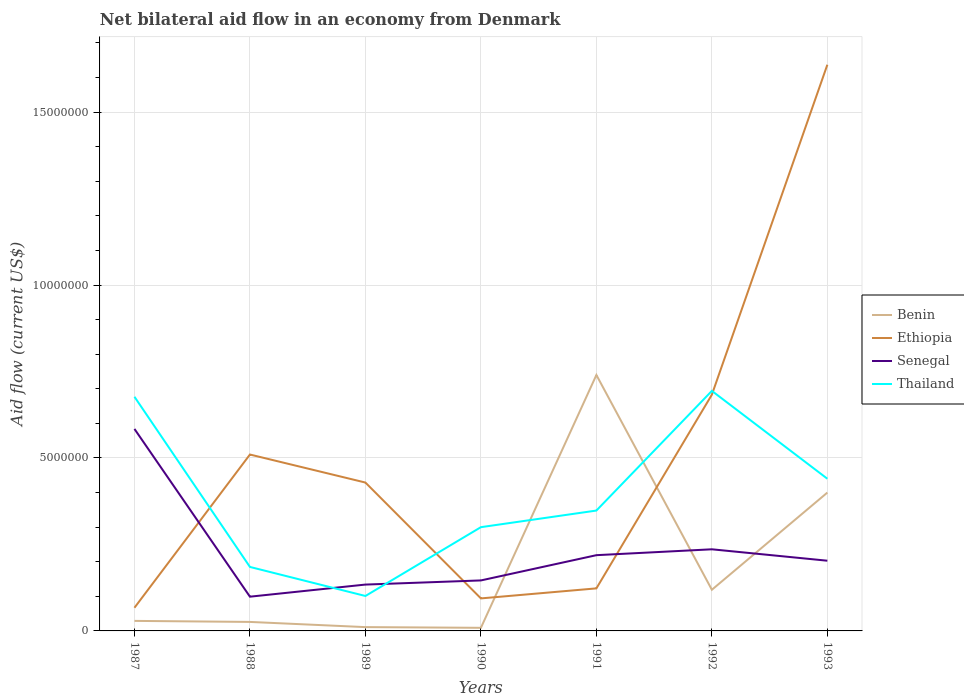Does the line corresponding to Benin intersect with the line corresponding to Ethiopia?
Offer a terse response. Yes. What is the total net bilateral aid flow in Thailand in the graph?
Your response must be concise. -4.80e+05. What is the difference between the highest and the second highest net bilateral aid flow in Ethiopia?
Provide a short and direct response. 1.57e+07. How many lines are there?
Your answer should be very brief. 4. Are the values on the major ticks of Y-axis written in scientific E-notation?
Your answer should be compact. No. Where does the legend appear in the graph?
Your response must be concise. Center right. How are the legend labels stacked?
Make the answer very short. Vertical. What is the title of the graph?
Offer a very short reply. Net bilateral aid flow in an economy from Denmark. What is the label or title of the X-axis?
Offer a very short reply. Years. What is the Aid flow (current US$) of Ethiopia in 1987?
Give a very brief answer. 6.70e+05. What is the Aid flow (current US$) in Senegal in 1987?
Ensure brevity in your answer.  5.84e+06. What is the Aid flow (current US$) in Thailand in 1987?
Your response must be concise. 6.77e+06. What is the Aid flow (current US$) in Ethiopia in 1988?
Offer a very short reply. 5.10e+06. What is the Aid flow (current US$) in Senegal in 1988?
Provide a short and direct response. 9.90e+05. What is the Aid flow (current US$) of Thailand in 1988?
Give a very brief answer. 1.85e+06. What is the Aid flow (current US$) in Ethiopia in 1989?
Your answer should be compact. 4.29e+06. What is the Aid flow (current US$) of Senegal in 1989?
Provide a succinct answer. 1.34e+06. What is the Aid flow (current US$) of Thailand in 1989?
Your answer should be compact. 1.01e+06. What is the Aid flow (current US$) in Ethiopia in 1990?
Your response must be concise. 9.40e+05. What is the Aid flow (current US$) in Senegal in 1990?
Give a very brief answer. 1.46e+06. What is the Aid flow (current US$) in Thailand in 1990?
Your answer should be compact. 3.00e+06. What is the Aid flow (current US$) in Benin in 1991?
Your answer should be compact. 7.40e+06. What is the Aid flow (current US$) in Ethiopia in 1991?
Ensure brevity in your answer.  1.23e+06. What is the Aid flow (current US$) in Senegal in 1991?
Your answer should be compact. 2.19e+06. What is the Aid flow (current US$) of Thailand in 1991?
Provide a short and direct response. 3.48e+06. What is the Aid flow (current US$) of Benin in 1992?
Make the answer very short. 1.19e+06. What is the Aid flow (current US$) in Ethiopia in 1992?
Your response must be concise. 6.83e+06. What is the Aid flow (current US$) of Senegal in 1992?
Provide a short and direct response. 2.36e+06. What is the Aid flow (current US$) of Thailand in 1992?
Your answer should be very brief. 6.94e+06. What is the Aid flow (current US$) in Benin in 1993?
Offer a terse response. 4.00e+06. What is the Aid flow (current US$) of Ethiopia in 1993?
Provide a succinct answer. 1.64e+07. What is the Aid flow (current US$) of Senegal in 1993?
Keep it short and to the point. 2.03e+06. What is the Aid flow (current US$) in Thailand in 1993?
Your answer should be compact. 4.40e+06. Across all years, what is the maximum Aid flow (current US$) of Benin?
Provide a succinct answer. 7.40e+06. Across all years, what is the maximum Aid flow (current US$) of Ethiopia?
Provide a short and direct response. 1.64e+07. Across all years, what is the maximum Aid flow (current US$) in Senegal?
Ensure brevity in your answer.  5.84e+06. Across all years, what is the maximum Aid flow (current US$) in Thailand?
Provide a succinct answer. 6.94e+06. Across all years, what is the minimum Aid flow (current US$) of Ethiopia?
Your answer should be compact. 6.70e+05. Across all years, what is the minimum Aid flow (current US$) in Senegal?
Provide a succinct answer. 9.90e+05. Across all years, what is the minimum Aid flow (current US$) in Thailand?
Offer a very short reply. 1.01e+06. What is the total Aid flow (current US$) of Benin in the graph?
Give a very brief answer. 1.33e+07. What is the total Aid flow (current US$) of Ethiopia in the graph?
Offer a terse response. 3.54e+07. What is the total Aid flow (current US$) of Senegal in the graph?
Offer a very short reply. 1.62e+07. What is the total Aid flow (current US$) of Thailand in the graph?
Give a very brief answer. 2.74e+07. What is the difference between the Aid flow (current US$) of Ethiopia in 1987 and that in 1988?
Give a very brief answer. -4.43e+06. What is the difference between the Aid flow (current US$) of Senegal in 1987 and that in 1988?
Your answer should be compact. 4.85e+06. What is the difference between the Aid flow (current US$) of Thailand in 1987 and that in 1988?
Provide a short and direct response. 4.92e+06. What is the difference between the Aid flow (current US$) of Benin in 1987 and that in 1989?
Your answer should be very brief. 1.80e+05. What is the difference between the Aid flow (current US$) in Ethiopia in 1987 and that in 1989?
Your response must be concise. -3.62e+06. What is the difference between the Aid flow (current US$) of Senegal in 1987 and that in 1989?
Give a very brief answer. 4.50e+06. What is the difference between the Aid flow (current US$) of Thailand in 1987 and that in 1989?
Ensure brevity in your answer.  5.76e+06. What is the difference between the Aid flow (current US$) in Benin in 1987 and that in 1990?
Provide a succinct answer. 2.00e+05. What is the difference between the Aid flow (current US$) in Senegal in 1987 and that in 1990?
Your response must be concise. 4.38e+06. What is the difference between the Aid flow (current US$) of Thailand in 1987 and that in 1990?
Provide a short and direct response. 3.77e+06. What is the difference between the Aid flow (current US$) of Benin in 1987 and that in 1991?
Keep it short and to the point. -7.11e+06. What is the difference between the Aid flow (current US$) of Ethiopia in 1987 and that in 1991?
Provide a succinct answer. -5.60e+05. What is the difference between the Aid flow (current US$) in Senegal in 1987 and that in 1991?
Provide a short and direct response. 3.65e+06. What is the difference between the Aid flow (current US$) in Thailand in 1987 and that in 1991?
Your answer should be very brief. 3.29e+06. What is the difference between the Aid flow (current US$) of Benin in 1987 and that in 1992?
Offer a very short reply. -9.00e+05. What is the difference between the Aid flow (current US$) of Ethiopia in 1987 and that in 1992?
Give a very brief answer. -6.16e+06. What is the difference between the Aid flow (current US$) in Senegal in 1987 and that in 1992?
Provide a succinct answer. 3.48e+06. What is the difference between the Aid flow (current US$) of Benin in 1987 and that in 1993?
Provide a short and direct response. -3.71e+06. What is the difference between the Aid flow (current US$) of Ethiopia in 1987 and that in 1993?
Ensure brevity in your answer.  -1.57e+07. What is the difference between the Aid flow (current US$) in Senegal in 1987 and that in 1993?
Your response must be concise. 3.81e+06. What is the difference between the Aid flow (current US$) in Thailand in 1987 and that in 1993?
Offer a very short reply. 2.37e+06. What is the difference between the Aid flow (current US$) in Ethiopia in 1988 and that in 1989?
Keep it short and to the point. 8.10e+05. What is the difference between the Aid flow (current US$) of Senegal in 1988 and that in 1989?
Keep it short and to the point. -3.50e+05. What is the difference between the Aid flow (current US$) in Thailand in 1988 and that in 1989?
Offer a terse response. 8.40e+05. What is the difference between the Aid flow (current US$) in Ethiopia in 1988 and that in 1990?
Your answer should be compact. 4.16e+06. What is the difference between the Aid flow (current US$) of Senegal in 1988 and that in 1990?
Keep it short and to the point. -4.70e+05. What is the difference between the Aid flow (current US$) in Thailand in 1988 and that in 1990?
Ensure brevity in your answer.  -1.15e+06. What is the difference between the Aid flow (current US$) of Benin in 1988 and that in 1991?
Give a very brief answer. -7.14e+06. What is the difference between the Aid flow (current US$) of Ethiopia in 1988 and that in 1991?
Provide a succinct answer. 3.87e+06. What is the difference between the Aid flow (current US$) of Senegal in 1988 and that in 1991?
Offer a very short reply. -1.20e+06. What is the difference between the Aid flow (current US$) in Thailand in 1988 and that in 1991?
Your answer should be compact. -1.63e+06. What is the difference between the Aid flow (current US$) of Benin in 1988 and that in 1992?
Offer a very short reply. -9.30e+05. What is the difference between the Aid flow (current US$) of Ethiopia in 1988 and that in 1992?
Offer a terse response. -1.73e+06. What is the difference between the Aid flow (current US$) in Senegal in 1988 and that in 1992?
Keep it short and to the point. -1.37e+06. What is the difference between the Aid flow (current US$) in Thailand in 1988 and that in 1992?
Make the answer very short. -5.09e+06. What is the difference between the Aid flow (current US$) in Benin in 1988 and that in 1993?
Give a very brief answer. -3.74e+06. What is the difference between the Aid flow (current US$) in Ethiopia in 1988 and that in 1993?
Offer a very short reply. -1.13e+07. What is the difference between the Aid flow (current US$) of Senegal in 1988 and that in 1993?
Provide a succinct answer. -1.04e+06. What is the difference between the Aid flow (current US$) of Thailand in 1988 and that in 1993?
Offer a terse response. -2.55e+06. What is the difference between the Aid flow (current US$) of Benin in 1989 and that in 1990?
Your answer should be very brief. 2.00e+04. What is the difference between the Aid flow (current US$) in Ethiopia in 1989 and that in 1990?
Make the answer very short. 3.35e+06. What is the difference between the Aid flow (current US$) of Thailand in 1989 and that in 1990?
Make the answer very short. -1.99e+06. What is the difference between the Aid flow (current US$) of Benin in 1989 and that in 1991?
Provide a short and direct response. -7.29e+06. What is the difference between the Aid flow (current US$) of Ethiopia in 1989 and that in 1991?
Provide a short and direct response. 3.06e+06. What is the difference between the Aid flow (current US$) in Senegal in 1989 and that in 1991?
Ensure brevity in your answer.  -8.50e+05. What is the difference between the Aid flow (current US$) in Thailand in 1989 and that in 1991?
Make the answer very short. -2.47e+06. What is the difference between the Aid flow (current US$) in Benin in 1989 and that in 1992?
Give a very brief answer. -1.08e+06. What is the difference between the Aid flow (current US$) of Ethiopia in 1989 and that in 1992?
Keep it short and to the point. -2.54e+06. What is the difference between the Aid flow (current US$) in Senegal in 1989 and that in 1992?
Your answer should be very brief. -1.02e+06. What is the difference between the Aid flow (current US$) of Thailand in 1989 and that in 1992?
Keep it short and to the point. -5.93e+06. What is the difference between the Aid flow (current US$) of Benin in 1989 and that in 1993?
Your answer should be very brief. -3.89e+06. What is the difference between the Aid flow (current US$) in Ethiopia in 1989 and that in 1993?
Your answer should be compact. -1.21e+07. What is the difference between the Aid flow (current US$) in Senegal in 1989 and that in 1993?
Ensure brevity in your answer.  -6.90e+05. What is the difference between the Aid flow (current US$) of Thailand in 1989 and that in 1993?
Your answer should be compact. -3.39e+06. What is the difference between the Aid flow (current US$) in Benin in 1990 and that in 1991?
Keep it short and to the point. -7.31e+06. What is the difference between the Aid flow (current US$) in Ethiopia in 1990 and that in 1991?
Offer a very short reply. -2.90e+05. What is the difference between the Aid flow (current US$) in Senegal in 1990 and that in 1991?
Offer a terse response. -7.30e+05. What is the difference between the Aid flow (current US$) in Thailand in 1990 and that in 1991?
Your answer should be very brief. -4.80e+05. What is the difference between the Aid flow (current US$) in Benin in 1990 and that in 1992?
Provide a short and direct response. -1.10e+06. What is the difference between the Aid flow (current US$) of Ethiopia in 1990 and that in 1992?
Offer a very short reply. -5.89e+06. What is the difference between the Aid flow (current US$) in Senegal in 1990 and that in 1992?
Offer a very short reply. -9.00e+05. What is the difference between the Aid flow (current US$) in Thailand in 1990 and that in 1992?
Offer a terse response. -3.94e+06. What is the difference between the Aid flow (current US$) of Benin in 1990 and that in 1993?
Offer a terse response. -3.91e+06. What is the difference between the Aid flow (current US$) of Ethiopia in 1990 and that in 1993?
Your response must be concise. -1.54e+07. What is the difference between the Aid flow (current US$) in Senegal in 1990 and that in 1993?
Keep it short and to the point. -5.70e+05. What is the difference between the Aid flow (current US$) of Thailand in 1990 and that in 1993?
Your answer should be compact. -1.40e+06. What is the difference between the Aid flow (current US$) of Benin in 1991 and that in 1992?
Provide a short and direct response. 6.21e+06. What is the difference between the Aid flow (current US$) of Ethiopia in 1991 and that in 1992?
Offer a very short reply. -5.60e+06. What is the difference between the Aid flow (current US$) of Senegal in 1991 and that in 1992?
Provide a succinct answer. -1.70e+05. What is the difference between the Aid flow (current US$) of Thailand in 1991 and that in 1992?
Offer a terse response. -3.46e+06. What is the difference between the Aid flow (current US$) of Benin in 1991 and that in 1993?
Provide a succinct answer. 3.40e+06. What is the difference between the Aid flow (current US$) of Ethiopia in 1991 and that in 1993?
Give a very brief answer. -1.51e+07. What is the difference between the Aid flow (current US$) of Senegal in 1991 and that in 1993?
Your answer should be compact. 1.60e+05. What is the difference between the Aid flow (current US$) of Thailand in 1991 and that in 1993?
Offer a very short reply. -9.20e+05. What is the difference between the Aid flow (current US$) of Benin in 1992 and that in 1993?
Give a very brief answer. -2.81e+06. What is the difference between the Aid flow (current US$) in Ethiopia in 1992 and that in 1993?
Offer a terse response. -9.54e+06. What is the difference between the Aid flow (current US$) of Thailand in 1992 and that in 1993?
Your answer should be very brief. 2.54e+06. What is the difference between the Aid flow (current US$) in Benin in 1987 and the Aid flow (current US$) in Ethiopia in 1988?
Provide a short and direct response. -4.81e+06. What is the difference between the Aid flow (current US$) of Benin in 1987 and the Aid flow (current US$) of Senegal in 1988?
Make the answer very short. -7.00e+05. What is the difference between the Aid flow (current US$) of Benin in 1987 and the Aid flow (current US$) of Thailand in 1988?
Your answer should be very brief. -1.56e+06. What is the difference between the Aid flow (current US$) of Ethiopia in 1987 and the Aid flow (current US$) of Senegal in 1988?
Provide a succinct answer. -3.20e+05. What is the difference between the Aid flow (current US$) of Ethiopia in 1987 and the Aid flow (current US$) of Thailand in 1988?
Provide a short and direct response. -1.18e+06. What is the difference between the Aid flow (current US$) in Senegal in 1987 and the Aid flow (current US$) in Thailand in 1988?
Your answer should be very brief. 3.99e+06. What is the difference between the Aid flow (current US$) of Benin in 1987 and the Aid flow (current US$) of Senegal in 1989?
Make the answer very short. -1.05e+06. What is the difference between the Aid flow (current US$) in Benin in 1987 and the Aid flow (current US$) in Thailand in 1989?
Your answer should be very brief. -7.20e+05. What is the difference between the Aid flow (current US$) of Ethiopia in 1987 and the Aid flow (current US$) of Senegal in 1989?
Your answer should be very brief. -6.70e+05. What is the difference between the Aid flow (current US$) in Ethiopia in 1987 and the Aid flow (current US$) in Thailand in 1989?
Provide a short and direct response. -3.40e+05. What is the difference between the Aid flow (current US$) of Senegal in 1987 and the Aid flow (current US$) of Thailand in 1989?
Provide a succinct answer. 4.83e+06. What is the difference between the Aid flow (current US$) of Benin in 1987 and the Aid flow (current US$) of Ethiopia in 1990?
Give a very brief answer. -6.50e+05. What is the difference between the Aid flow (current US$) of Benin in 1987 and the Aid flow (current US$) of Senegal in 1990?
Provide a succinct answer. -1.17e+06. What is the difference between the Aid flow (current US$) in Benin in 1987 and the Aid flow (current US$) in Thailand in 1990?
Provide a short and direct response. -2.71e+06. What is the difference between the Aid flow (current US$) in Ethiopia in 1987 and the Aid flow (current US$) in Senegal in 1990?
Give a very brief answer. -7.90e+05. What is the difference between the Aid flow (current US$) of Ethiopia in 1987 and the Aid flow (current US$) of Thailand in 1990?
Give a very brief answer. -2.33e+06. What is the difference between the Aid flow (current US$) of Senegal in 1987 and the Aid flow (current US$) of Thailand in 1990?
Offer a terse response. 2.84e+06. What is the difference between the Aid flow (current US$) in Benin in 1987 and the Aid flow (current US$) in Ethiopia in 1991?
Offer a terse response. -9.40e+05. What is the difference between the Aid flow (current US$) in Benin in 1987 and the Aid flow (current US$) in Senegal in 1991?
Provide a short and direct response. -1.90e+06. What is the difference between the Aid flow (current US$) of Benin in 1987 and the Aid flow (current US$) of Thailand in 1991?
Your answer should be compact. -3.19e+06. What is the difference between the Aid flow (current US$) in Ethiopia in 1987 and the Aid flow (current US$) in Senegal in 1991?
Your response must be concise. -1.52e+06. What is the difference between the Aid flow (current US$) in Ethiopia in 1987 and the Aid flow (current US$) in Thailand in 1991?
Give a very brief answer. -2.81e+06. What is the difference between the Aid flow (current US$) of Senegal in 1987 and the Aid flow (current US$) of Thailand in 1991?
Provide a succinct answer. 2.36e+06. What is the difference between the Aid flow (current US$) in Benin in 1987 and the Aid flow (current US$) in Ethiopia in 1992?
Offer a terse response. -6.54e+06. What is the difference between the Aid flow (current US$) in Benin in 1987 and the Aid flow (current US$) in Senegal in 1992?
Your response must be concise. -2.07e+06. What is the difference between the Aid flow (current US$) of Benin in 1987 and the Aid flow (current US$) of Thailand in 1992?
Keep it short and to the point. -6.65e+06. What is the difference between the Aid flow (current US$) of Ethiopia in 1987 and the Aid flow (current US$) of Senegal in 1992?
Keep it short and to the point. -1.69e+06. What is the difference between the Aid flow (current US$) in Ethiopia in 1987 and the Aid flow (current US$) in Thailand in 1992?
Offer a very short reply. -6.27e+06. What is the difference between the Aid flow (current US$) of Senegal in 1987 and the Aid flow (current US$) of Thailand in 1992?
Keep it short and to the point. -1.10e+06. What is the difference between the Aid flow (current US$) of Benin in 1987 and the Aid flow (current US$) of Ethiopia in 1993?
Your answer should be compact. -1.61e+07. What is the difference between the Aid flow (current US$) in Benin in 1987 and the Aid flow (current US$) in Senegal in 1993?
Offer a terse response. -1.74e+06. What is the difference between the Aid flow (current US$) in Benin in 1987 and the Aid flow (current US$) in Thailand in 1993?
Keep it short and to the point. -4.11e+06. What is the difference between the Aid flow (current US$) of Ethiopia in 1987 and the Aid flow (current US$) of Senegal in 1993?
Make the answer very short. -1.36e+06. What is the difference between the Aid flow (current US$) of Ethiopia in 1987 and the Aid flow (current US$) of Thailand in 1993?
Your response must be concise. -3.73e+06. What is the difference between the Aid flow (current US$) in Senegal in 1987 and the Aid flow (current US$) in Thailand in 1993?
Provide a short and direct response. 1.44e+06. What is the difference between the Aid flow (current US$) of Benin in 1988 and the Aid flow (current US$) of Ethiopia in 1989?
Your answer should be compact. -4.03e+06. What is the difference between the Aid flow (current US$) of Benin in 1988 and the Aid flow (current US$) of Senegal in 1989?
Give a very brief answer. -1.08e+06. What is the difference between the Aid flow (current US$) in Benin in 1988 and the Aid flow (current US$) in Thailand in 1989?
Provide a succinct answer. -7.50e+05. What is the difference between the Aid flow (current US$) of Ethiopia in 1988 and the Aid flow (current US$) of Senegal in 1989?
Keep it short and to the point. 3.76e+06. What is the difference between the Aid flow (current US$) in Ethiopia in 1988 and the Aid flow (current US$) in Thailand in 1989?
Keep it short and to the point. 4.09e+06. What is the difference between the Aid flow (current US$) of Senegal in 1988 and the Aid flow (current US$) of Thailand in 1989?
Your response must be concise. -2.00e+04. What is the difference between the Aid flow (current US$) of Benin in 1988 and the Aid flow (current US$) of Ethiopia in 1990?
Ensure brevity in your answer.  -6.80e+05. What is the difference between the Aid flow (current US$) of Benin in 1988 and the Aid flow (current US$) of Senegal in 1990?
Provide a short and direct response. -1.20e+06. What is the difference between the Aid flow (current US$) of Benin in 1988 and the Aid flow (current US$) of Thailand in 1990?
Give a very brief answer. -2.74e+06. What is the difference between the Aid flow (current US$) in Ethiopia in 1988 and the Aid flow (current US$) in Senegal in 1990?
Ensure brevity in your answer.  3.64e+06. What is the difference between the Aid flow (current US$) in Ethiopia in 1988 and the Aid flow (current US$) in Thailand in 1990?
Offer a very short reply. 2.10e+06. What is the difference between the Aid flow (current US$) in Senegal in 1988 and the Aid flow (current US$) in Thailand in 1990?
Provide a short and direct response. -2.01e+06. What is the difference between the Aid flow (current US$) of Benin in 1988 and the Aid flow (current US$) of Ethiopia in 1991?
Give a very brief answer. -9.70e+05. What is the difference between the Aid flow (current US$) of Benin in 1988 and the Aid flow (current US$) of Senegal in 1991?
Offer a very short reply. -1.93e+06. What is the difference between the Aid flow (current US$) of Benin in 1988 and the Aid flow (current US$) of Thailand in 1991?
Offer a terse response. -3.22e+06. What is the difference between the Aid flow (current US$) in Ethiopia in 1988 and the Aid flow (current US$) in Senegal in 1991?
Offer a terse response. 2.91e+06. What is the difference between the Aid flow (current US$) in Ethiopia in 1988 and the Aid flow (current US$) in Thailand in 1991?
Your response must be concise. 1.62e+06. What is the difference between the Aid flow (current US$) of Senegal in 1988 and the Aid flow (current US$) of Thailand in 1991?
Provide a short and direct response. -2.49e+06. What is the difference between the Aid flow (current US$) in Benin in 1988 and the Aid flow (current US$) in Ethiopia in 1992?
Your answer should be compact. -6.57e+06. What is the difference between the Aid flow (current US$) of Benin in 1988 and the Aid flow (current US$) of Senegal in 1992?
Provide a short and direct response. -2.10e+06. What is the difference between the Aid flow (current US$) in Benin in 1988 and the Aid flow (current US$) in Thailand in 1992?
Your answer should be very brief. -6.68e+06. What is the difference between the Aid flow (current US$) of Ethiopia in 1988 and the Aid flow (current US$) of Senegal in 1992?
Your answer should be very brief. 2.74e+06. What is the difference between the Aid flow (current US$) of Ethiopia in 1988 and the Aid flow (current US$) of Thailand in 1992?
Your response must be concise. -1.84e+06. What is the difference between the Aid flow (current US$) in Senegal in 1988 and the Aid flow (current US$) in Thailand in 1992?
Ensure brevity in your answer.  -5.95e+06. What is the difference between the Aid flow (current US$) of Benin in 1988 and the Aid flow (current US$) of Ethiopia in 1993?
Give a very brief answer. -1.61e+07. What is the difference between the Aid flow (current US$) of Benin in 1988 and the Aid flow (current US$) of Senegal in 1993?
Provide a succinct answer. -1.77e+06. What is the difference between the Aid flow (current US$) in Benin in 1988 and the Aid flow (current US$) in Thailand in 1993?
Keep it short and to the point. -4.14e+06. What is the difference between the Aid flow (current US$) of Ethiopia in 1988 and the Aid flow (current US$) of Senegal in 1993?
Offer a terse response. 3.07e+06. What is the difference between the Aid flow (current US$) in Ethiopia in 1988 and the Aid flow (current US$) in Thailand in 1993?
Your answer should be very brief. 7.00e+05. What is the difference between the Aid flow (current US$) of Senegal in 1988 and the Aid flow (current US$) of Thailand in 1993?
Offer a very short reply. -3.41e+06. What is the difference between the Aid flow (current US$) of Benin in 1989 and the Aid flow (current US$) of Ethiopia in 1990?
Provide a succinct answer. -8.30e+05. What is the difference between the Aid flow (current US$) in Benin in 1989 and the Aid flow (current US$) in Senegal in 1990?
Provide a short and direct response. -1.35e+06. What is the difference between the Aid flow (current US$) of Benin in 1989 and the Aid flow (current US$) of Thailand in 1990?
Keep it short and to the point. -2.89e+06. What is the difference between the Aid flow (current US$) of Ethiopia in 1989 and the Aid flow (current US$) of Senegal in 1990?
Your answer should be compact. 2.83e+06. What is the difference between the Aid flow (current US$) of Ethiopia in 1989 and the Aid flow (current US$) of Thailand in 1990?
Offer a very short reply. 1.29e+06. What is the difference between the Aid flow (current US$) in Senegal in 1989 and the Aid flow (current US$) in Thailand in 1990?
Ensure brevity in your answer.  -1.66e+06. What is the difference between the Aid flow (current US$) in Benin in 1989 and the Aid flow (current US$) in Ethiopia in 1991?
Provide a succinct answer. -1.12e+06. What is the difference between the Aid flow (current US$) in Benin in 1989 and the Aid flow (current US$) in Senegal in 1991?
Keep it short and to the point. -2.08e+06. What is the difference between the Aid flow (current US$) of Benin in 1989 and the Aid flow (current US$) of Thailand in 1991?
Your answer should be very brief. -3.37e+06. What is the difference between the Aid flow (current US$) in Ethiopia in 1989 and the Aid flow (current US$) in Senegal in 1991?
Keep it short and to the point. 2.10e+06. What is the difference between the Aid flow (current US$) of Ethiopia in 1989 and the Aid flow (current US$) of Thailand in 1991?
Make the answer very short. 8.10e+05. What is the difference between the Aid flow (current US$) of Senegal in 1989 and the Aid flow (current US$) of Thailand in 1991?
Your response must be concise. -2.14e+06. What is the difference between the Aid flow (current US$) in Benin in 1989 and the Aid flow (current US$) in Ethiopia in 1992?
Offer a very short reply. -6.72e+06. What is the difference between the Aid flow (current US$) in Benin in 1989 and the Aid flow (current US$) in Senegal in 1992?
Keep it short and to the point. -2.25e+06. What is the difference between the Aid flow (current US$) in Benin in 1989 and the Aid flow (current US$) in Thailand in 1992?
Your answer should be very brief. -6.83e+06. What is the difference between the Aid flow (current US$) of Ethiopia in 1989 and the Aid flow (current US$) of Senegal in 1992?
Keep it short and to the point. 1.93e+06. What is the difference between the Aid flow (current US$) in Ethiopia in 1989 and the Aid flow (current US$) in Thailand in 1992?
Your answer should be very brief. -2.65e+06. What is the difference between the Aid flow (current US$) in Senegal in 1989 and the Aid flow (current US$) in Thailand in 1992?
Give a very brief answer. -5.60e+06. What is the difference between the Aid flow (current US$) in Benin in 1989 and the Aid flow (current US$) in Ethiopia in 1993?
Offer a terse response. -1.63e+07. What is the difference between the Aid flow (current US$) of Benin in 1989 and the Aid flow (current US$) of Senegal in 1993?
Your answer should be very brief. -1.92e+06. What is the difference between the Aid flow (current US$) in Benin in 1989 and the Aid flow (current US$) in Thailand in 1993?
Provide a succinct answer. -4.29e+06. What is the difference between the Aid flow (current US$) in Ethiopia in 1989 and the Aid flow (current US$) in Senegal in 1993?
Keep it short and to the point. 2.26e+06. What is the difference between the Aid flow (current US$) of Senegal in 1989 and the Aid flow (current US$) of Thailand in 1993?
Offer a very short reply. -3.06e+06. What is the difference between the Aid flow (current US$) of Benin in 1990 and the Aid flow (current US$) of Ethiopia in 1991?
Offer a very short reply. -1.14e+06. What is the difference between the Aid flow (current US$) in Benin in 1990 and the Aid flow (current US$) in Senegal in 1991?
Offer a very short reply. -2.10e+06. What is the difference between the Aid flow (current US$) of Benin in 1990 and the Aid flow (current US$) of Thailand in 1991?
Provide a short and direct response. -3.39e+06. What is the difference between the Aid flow (current US$) of Ethiopia in 1990 and the Aid flow (current US$) of Senegal in 1991?
Your answer should be compact. -1.25e+06. What is the difference between the Aid flow (current US$) in Ethiopia in 1990 and the Aid flow (current US$) in Thailand in 1991?
Offer a very short reply. -2.54e+06. What is the difference between the Aid flow (current US$) of Senegal in 1990 and the Aid flow (current US$) of Thailand in 1991?
Your answer should be compact. -2.02e+06. What is the difference between the Aid flow (current US$) of Benin in 1990 and the Aid flow (current US$) of Ethiopia in 1992?
Your response must be concise. -6.74e+06. What is the difference between the Aid flow (current US$) of Benin in 1990 and the Aid flow (current US$) of Senegal in 1992?
Your answer should be very brief. -2.27e+06. What is the difference between the Aid flow (current US$) of Benin in 1990 and the Aid flow (current US$) of Thailand in 1992?
Offer a terse response. -6.85e+06. What is the difference between the Aid flow (current US$) of Ethiopia in 1990 and the Aid flow (current US$) of Senegal in 1992?
Keep it short and to the point. -1.42e+06. What is the difference between the Aid flow (current US$) in Ethiopia in 1990 and the Aid flow (current US$) in Thailand in 1992?
Provide a short and direct response. -6.00e+06. What is the difference between the Aid flow (current US$) in Senegal in 1990 and the Aid flow (current US$) in Thailand in 1992?
Offer a very short reply. -5.48e+06. What is the difference between the Aid flow (current US$) in Benin in 1990 and the Aid flow (current US$) in Ethiopia in 1993?
Offer a very short reply. -1.63e+07. What is the difference between the Aid flow (current US$) of Benin in 1990 and the Aid flow (current US$) of Senegal in 1993?
Give a very brief answer. -1.94e+06. What is the difference between the Aid flow (current US$) in Benin in 1990 and the Aid flow (current US$) in Thailand in 1993?
Offer a very short reply. -4.31e+06. What is the difference between the Aid flow (current US$) of Ethiopia in 1990 and the Aid flow (current US$) of Senegal in 1993?
Offer a terse response. -1.09e+06. What is the difference between the Aid flow (current US$) of Ethiopia in 1990 and the Aid flow (current US$) of Thailand in 1993?
Provide a succinct answer. -3.46e+06. What is the difference between the Aid flow (current US$) of Senegal in 1990 and the Aid flow (current US$) of Thailand in 1993?
Ensure brevity in your answer.  -2.94e+06. What is the difference between the Aid flow (current US$) in Benin in 1991 and the Aid flow (current US$) in Ethiopia in 1992?
Offer a very short reply. 5.70e+05. What is the difference between the Aid flow (current US$) of Benin in 1991 and the Aid flow (current US$) of Senegal in 1992?
Ensure brevity in your answer.  5.04e+06. What is the difference between the Aid flow (current US$) of Benin in 1991 and the Aid flow (current US$) of Thailand in 1992?
Provide a short and direct response. 4.60e+05. What is the difference between the Aid flow (current US$) in Ethiopia in 1991 and the Aid flow (current US$) in Senegal in 1992?
Make the answer very short. -1.13e+06. What is the difference between the Aid flow (current US$) in Ethiopia in 1991 and the Aid flow (current US$) in Thailand in 1992?
Your answer should be very brief. -5.71e+06. What is the difference between the Aid flow (current US$) in Senegal in 1991 and the Aid flow (current US$) in Thailand in 1992?
Provide a succinct answer. -4.75e+06. What is the difference between the Aid flow (current US$) in Benin in 1991 and the Aid flow (current US$) in Ethiopia in 1993?
Ensure brevity in your answer.  -8.97e+06. What is the difference between the Aid flow (current US$) of Benin in 1991 and the Aid flow (current US$) of Senegal in 1993?
Ensure brevity in your answer.  5.37e+06. What is the difference between the Aid flow (current US$) of Ethiopia in 1991 and the Aid flow (current US$) of Senegal in 1993?
Give a very brief answer. -8.00e+05. What is the difference between the Aid flow (current US$) of Ethiopia in 1991 and the Aid flow (current US$) of Thailand in 1993?
Ensure brevity in your answer.  -3.17e+06. What is the difference between the Aid flow (current US$) of Senegal in 1991 and the Aid flow (current US$) of Thailand in 1993?
Give a very brief answer. -2.21e+06. What is the difference between the Aid flow (current US$) in Benin in 1992 and the Aid flow (current US$) in Ethiopia in 1993?
Make the answer very short. -1.52e+07. What is the difference between the Aid flow (current US$) of Benin in 1992 and the Aid flow (current US$) of Senegal in 1993?
Provide a short and direct response. -8.40e+05. What is the difference between the Aid flow (current US$) of Benin in 1992 and the Aid flow (current US$) of Thailand in 1993?
Ensure brevity in your answer.  -3.21e+06. What is the difference between the Aid flow (current US$) of Ethiopia in 1992 and the Aid flow (current US$) of Senegal in 1993?
Provide a short and direct response. 4.80e+06. What is the difference between the Aid flow (current US$) of Ethiopia in 1992 and the Aid flow (current US$) of Thailand in 1993?
Provide a succinct answer. 2.43e+06. What is the difference between the Aid flow (current US$) of Senegal in 1992 and the Aid flow (current US$) of Thailand in 1993?
Give a very brief answer. -2.04e+06. What is the average Aid flow (current US$) of Benin per year?
Make the answer very short. 1.91e+06. What is the average Aid flow (current US$) in Ethiopia per year?
Provide a succinct answer. 5.06e+06. What is the average Aid flow (current US$) in Senegal per year?
Your response must be concise. 2.32e+06. What is the average Aid flow (current US$) in Thailand per year?
Offer a very short reply. 3.92e+06. In the year 1987, what is the difference between the Aid flow (current US$) in Benin and Aid flow (current US$) in Ethiopia?
Offer a very short reply. -3.80e+05. In the year 1987, what is the difference between the Aid flow (current US$) in Benin and Aid flow (current US$) in Senegal?
Offer a very short reply. -5.55e+06. In the year 1987, what is the difference between the Aid flow (current US$) of Benin and Aid flow (current US$) of Thailand?
Give a very brief answer. -6.48e+06. In the year 1987, what is the difference between the Aid flow (current US$) of Ethiopia and Aid flow (current US$) of Senegal?
Provide a succinct answer. -5.17e+06. In the year 1987, what is the difference between the Aid flow (current US$) in Ethiopia and Aid flow (current US$) in Thailand?
Provide a succinct answer. -6.10e+06. In the year 1987, what is the difference between the Aid flow (current US$) in Senegal and Aid flow (current US$) in Thailand?
Your answer should be compact. -9.30e+05. In the year 1988, what is the difference between the Aid flow (current US$) in Benin and Aid flow (current US$) in Ethiopia?
Offer a very short reply. -4.84e+06. In the year 1988, what is the difference between the Aid flow (current US$) in Benin and Aid flow (current US$) in Senegal?
Your response must be concise. -7.30e+05. In the year 1988, what is the difference between the Aid flow (current US$) of Benin and Aid flow (current US$) of Thailand?
Provide a short and direct response. -1.59e+06. In the year 1988, what is the difference between the Aid flow (current US$) of Ethiopia and Aid flow (current US$) of Senegal?
Give a very brief answer. 4.11e+06. In the year 1988, what is the difference between the Aid flow (current US$) in Ethiopia and Aid flow (current US$) in Thailand?
Provide a succinct answer. 3.25e+06. In the year 1988, what is the difference between the Aid flow (current US$) of Senegal and Aid flow (current US$) of Thailand?
Your response must be concise. -8.60e+05. In the year 1989, what is the difference between the Aid flow (current US$) of Benin and Aid flow (current US$) of Ethiopia?
Your answer should be compact. -4.18e+06. In the year 1989, what is the difference between the Aid flow (current US$) in Benin and Aid flow (current US$) in Senegal?
Make the answer very short. -1.23e+06. In the year 1989, what is the difference between the Aid flow (current US$) in Benin and Aid flow (current US$) in Thailand?
Provide a short and direct response. -9.00e+05. In the year 1989, what is the difference between the Aid flow (current US$) of Ethiopia and Aid flow (current US$) of Senegal?
Provide a succinct answer. 2.95e+06. In the year 1989, what is the difference between the Aid flow (current US$) of Ethiopia and Aid flow (current US$) of Thailand?
Offer a very short reply. 3.28e+06. In the year 1990, what is the difference between the Aid flow (current US$) in Benin and Aid flow (current US$) in Ethiopia?
Provide a short and direct response. -8.50e+05. In the year 1990, what is the difference between the Aid flow (current US$) of Benin and Aid flow (current US$) of Senegal?
Make the answer very short. -1.37e+06. In the year 1990, what is the difference between the Aid flow (current US$) in Benin and Aid flow (current US$) in Thailand?
Your answer should be very brief. -2.91e+06. In the year 1990, what is the difference between the Aid flow (current US$) in Ethiopia and Aid flow (current US$) in Senegal?
Provide a short and direct response. -5.20e+05. In the year 1990, what is the difference between the Aid flow (current US$) in Ethiopia and Aid flow (current US$) in Thailand?
Your answer should be very brief. -2.06e+06. In the year 1990, what is the difference between the Aid flow (current US$) of Senegal and Aid flow (current US$) of Thailand?
Ensure brevity in your answer.  -1.54e+06. In the year 1991, what is the difference between the Aid flow (current US$) of Benin and Aid flow (current US$) of Ethiopia?
Your answer should be very brief. 6.17e+06. In the year 1991, what is the difference between the Aid flow (current US$) of Benin and Aid flow (current US$) of Senegal?
Provide a short and direct response. 5.21e+06. In the year 1991, what is the difference between the Aid flow (current US$) in Benin and Aid flow (current US$) in Thailand?
Offer a very short reply. 3.92e+06. In the year 1991, what is the difference between the Aid flow (current US$) in Ethiopia and Aid flow (current US$) in Senegal?
Offer a terse response. -9.60e+05. In the year 1991, what is the difference between the Aid flow (current US$) of Ethiopia and Aid flow (current US$) of Thailand?
Keep it short and to the point. -2.25e+06. In the year 1991, what is the difference between the Aid flow (current US$) of Senegal and Aid flow (current US$) of Thailand?
Offer a very short reply. -1.29e+06. In the year 1992, what is the difference between the Aid flow (current US$) in Benin and Aid flow (current US$) in Ethiopia?
Keep it short and to the point. -5.64e+06. In the year 1992, what is the difference between the Aid flow (current US$) of Benin and Aid flow (current US$) of Senegal?
Ensure brevity in your answer.  -1.17e+06. In the year 1992, what is the difference between the Aid flow (current US$) of Benin and Aid flow (current US$) of Thailand?
Give a very brief answer. -5.75e+06. In the year 1992, what is the difference between the Aid flow (current US$) of Ethiopia and Aid flow (current US$) of Senegal?
Your response must be concise. 4.47e+06. In the year 1992, what is the difference between the Aid flow (current US$) in Senegal and Aid flow (current US$) in Thailand?
Ensure brevity in your answer.  -4.58e+06. In the year 1993, what is the difference between the Aid flow (current US$) in Benin and Aid flow (current US$) in Ethiopia?
Ensure brevity in your answer.  -1.24e+07. In the year 1993, what is the difference between the Aid flow (current US$) of Benin and Aid flow (current US$) of Senegal?
Offer a terse response. 1.97e+06. In the year 1993, what is the difference between the Aid flow (current US$) in Benin and Aid flow (current US$) in Thailand?
Offer a terse response. -4.00e+05. In the year 1993, what is the difference between the Aid flow (current US$) in Ethiopia and Aid flow (current US$) in Senegal?
Offer a very short reply. 1.43e+07. In the year 1993, what is the difference between the Aid flow (current US$) of Ethiopia and Aid flow (current US$) of Thailand?
Give a very brief answer. 1.20e+07. In the year 1993, what is the difference between the Aid flow (current US$) in Senegal and Aid flow (current US$) in Thailand?
Offer a very short reply. -2.37e+06. What is the ratio of the Aid flow (current US$) in Benin in 1987 to that in 1988?
Make the answer very short. 1.12. What is the ratio of the Aid flow (current US$) in Ethiopia in 1987 to that in 1988?
Offer a terse response. 0.13. What is the ratio of the Aid flow (current US$) of Senegal in 1987 to that in 1988?
Your answer should be compact. 5.9. What is the ratio of the Aid flow (current US$) in Thailand in 1987 to that in 1988?
Offer a terse response. 3.66. What is the ratio of the Aid flow (current US$) in Benin in 1987 to that in 1989?
Provide a succinct answer. 2.64. What is the ratio of the Aid flow (current US$) in Ethiopia in 1987 to that in 1989?
Your response must be concise. 0.16. What is the ratio of the Aid flow (current US$) of Senegal in 1987 to that in 1989?
Give a very brief answer. 4.36. What is the ratio of the Aid flow (current US$) in Thailand in 1987 to that in 1989?
Your answer should be very brief. 6.7. What is the ratio of the Aid flow (current US$) in Benin in 1987 to that in 1990?
Provide a succinct answer. 3.22. What is the ratio of the Aid flow (current US$) of Ethiopia in 1987 to that in 1990?
Ensure brevity in your answer.  0.71. What is the ratio of the Aid flow (current US$) of Senegal in 1987 to that in 1990?
Provide a succinct answer. 4. What is the ratio of the Aid flow (current US$) of Thailand in 1987 to that in 1990?
Ensure brevity in your answer.  2.26. What is the ratio of the Aid flow (current US$) in Benin in 1987 to that in 1991?
Offer a very short reply. 0.04. What is the ratio of the Aid flow (current US$) in Ethiopia in 1987 to that in 1991?
Your answer should be compact. 0.54. What is the ratio of the Aid flow (current US$) of Senegal in 1987 to that in 1991?
Your answer should be compact. 2.67. What is the ratio of the Aid flow (current US$) in Thailand in 1987 to that in 1991?
Ensure brevity in your answer.  1.95. What is the ratio of the Aid flow (current US$) of Benin in 1987 to that in 1992?
Your response must be concise. 0.24. What is the ratio of the Aid flow (current US$) of Ethiopia in 1987 to that in 1992?
Provide a succinct answer. 0.1. What is the ratio of the Aid flow (current US$) in Senegal in 1987 to that in 1992?
Your response must be concise. 2.47. What is the ratio of the Aid flow (current US$) in Thailand in 1987 to that in 1992?
Offer a very short reply. 0.98. What is the ratio of the Aid flow (current US$) in Benin in 1987 to that in 1993?
Provide a succinct answer. 0.07. What is the ratio of the Aid flow (current US$) in Ethiopia in 1987 to that in 1993?
Keep it short and to the point. 0.04. What is the ratio of the Aid flow (current US$) in Senegal in 1987 to that in 1993?
Your answer should be compact. 2.88. What is the ratio of the Aid flow (current US$) in Thailand in 1987 to that in 1993?
Your answer should be very brief. 1.54. What is the ratio of the Aid flow (current US$) of Benin in 1988 to that in 1989?
Keep it short and to the point. 2.36. What is the ratio of the Aid flow (current US$) in Ethiopia in 1988 to that in 1989?
Give a very brief answer. 1.19. What is the ratio of the Aid flow (current US$) of Senegal in 1988 to that in 1989?
Keep it short and to the point. 0.74. What is the ratio of the Aid flow (current US$) in Thailand in 1988 to that in 1989?
Offer a very short reply. 1.83. What is the ratio of the Aid flow (current US$) of Benin in 1988 to that in 1990?
Offer a terse response. 2.89. What is the ratio of the Aid flow (current US$) of Ethiopia in 1988 to that in 1990?
Make the answer very short. 5.43. What is the ratio of the Aid flow (current US$) in Senegal in 1988 to that in 1990?
Give a very brief answer. 0.68. What is the ratio of the Aid flow (current US$) of Thailand in 1988 to that in 1990?
Offer a very short reply. 0.62. What is the ratio of the Aid flow (current US$) in Benin in 1988 to that in 1991?
Make the answer very short. 0.04. What is the ratio of the Aid flow (current US$) of Ethiopia in 1988 to that in 1991?
Your answer should be very brief. 4.15. What is the ratio of the Aid flow (current US$) in Senegal in 1988 to that in 1991?
Make the answer very short. 0.45. What is the ratio of the Aid flow (current US$) in Thailand in 1988 to that in 1991?
Keep it short and to the point. 0.53. What is the ratio of the Aid flow (current US$) of Benin in 1988 to that in 1992?
Your answer should be very brief. 0.22. What is the ratio of the Aid flow (current US$) of Ethiopia in 1988 to that in 1992?
Keep it short and to the point. 0.75. What is the ratio of the Aid flow (current US$) in Senegal in 1988 to that in 1992?
Keep it short and to the point. 0.42. What is the ratio of the Aid flow (current US$) in Thailand in 1988 to that in 1992?
Your answer should be very brief. 0.27. What is the ratio of the Aid flow (current US$) in Benin in 1988 to that in 1993?
Your answer should be compact. 0.07. What is the ratio of the Aid flow (current US$) of Ethiopia in 1988 to that in 1993?
Your answer should be very brief. 0.31. What is the ratio of the Aid flow (current US$) in Senegal in 1988 to that in 1993?
Keep it short and to the point. 0.49. What is the ratio of the Aid flow (current US$) in Thailand in 1988 to that in 1993?
Offer a very short reply. 0.42. What is the ratio of the Aid flow (current US$) in Benin in 1989 to that in 1990?
Your answer should be very brief. 1.22. What is the ratio of the Aid flow (current US$) in Ethiopia in 1989 to that in 1990?
Your response must be concise. 4.56. What is the ratio of the Aid flow (current US$) in Senegal in 1989 to that in 1990?
Your answer should be very brief. 0.92. What is the ratio of the Aid flow (current US$) of Thailand in 1989 to that in 1990?
Make the answer very short. 0.34. What is the ratio of the Aid flow (current US$) of Benin in 1989 to that in 1991?
Offer a terse response. 0.01. What is the ratio of the Aid flow (current US$) in Ethiopia in 1989 to that in 1991?
Offer a terse response. 3.49. What is the ratio of the Aid flow (current US$) in Senegal in 1989 to that in 1991?
Provide a short and direct response. 0.61. What is the ratio of the Aid flow (current US$) of Thailand in 1989 to that in 1991?
Offer a very short reply. 0.29. What is the ratio of the Aid flow (current US$) in Benin in 1989 to that in 1992?
Your answer should be very brief. 0.09. What is the ratio of the Aid flow (current US$) of Ethiopia in 1989 to that in 1992?
Keep it short and to the point. 0.63. What is the ratio of the Aid flow (current US$) of Senegal in 1989 to that in 1992?
Make the answer very short. 0.57. What is the ratio of the Aid flow (current US$) in Thailand in 1989 to that in 1992?
Offer a terse response. 0.15. What is the ratio of the Aid flow (current US$) in Benin in 1989 to that in 1993?
Give a very brief answer. 0.03. What is the ratio of the Aid flow (current US$) in Ethiopia in 1989 to that in 1993?
Make the answer very short. 0.26. What is the ratio of the Aid flow (current US$) in Senegal in 1989 to that in 1993?
Offer a terse response. 0.66. What is the ratio of the Aid flow (current US$) of Thailand in 1989 to that in 1993?
Your response must be concise. 0.23. What is the ratio of the Aid flow (current US$) of Benin in 1990 to that in 1991?
Make the answer very short. 0.01. What is the ratio of the Aid flow (current US$) of Ethiopia in 1990 to that in 1991?
Keep it short and to the point. 0.76. What is the ratio of the Aid flow (current US$) of Senegal in 1990 to that in 1991?
Keep it short and to the point. 0.67. What is the ratio of the Aid flow (current US$) of Thailand in 1990 to that in 1991?
Provide a succinct answer. 0.86. What is the ratio of the Aid flow (current US$) in Benin in 1990 to that in 1992?
Provide a succinct answer. 0.08. What is the ratio of the Aid flow (current US$) of Ethiopia in 1990 to that in 1992?
Give a very brief answer. 0.14. What is the ratio of the Aid flow (current US$) of Senegal in 1990 to that in 1992?
Your answer should be compact. 0.62. What is the ratio of the Aid flow (current US$) of Thailand in 1990 to that in 1992?
Provide a succinct answer. 0.43. What is the ratio of the Aid flow (current US$) in Benin in 1990 to that in 1993?
Ensure brevity in your answer.  0.02. What is the ratio of the Aid flow (current US$) of Ethiopia in 1990 to that in 1993?
Your answer should be compact. 0.06. What is the ratio of the Aid flow (current US$) of Senegal in 1990 to that in 1993?
Your answer should be compact. 0.72. What is the ratio of the Aid flow (current US$) of Thailand in 1990 to that in 1993?
Ensure brevity in your answer.  0.68. What is the ratio of the Aid flow (current US$) in Benin in 1991 to that in 1992?
Provide a succinct answer. 6.22. What is the ratio of the Aid flow (current US$) in Ethiopia in 1991 to that in 1992?
Give a very brief answer. 0.18. What is the ratio of the Aid flow (current US$) in Senegal in 1991 to that in 1992?
Your answer should be very brief. 0.93. What is the ratio of the Aid flow (current US$) of Thailand in 1991 to that in 1992?
Give a very brief answer. 0.5. What is the ratio of the Aid flow (current US$) of Benin in 1991 to that in 1993?
Ensure brevity in your answer.  1.85. What is the ratio of the Aid flow (current US$) of Ethiopia in 1991 to that in 1993?
Your response must be concise. 0.08. What is the ratio of the Aid flow (current US$) of Senegal in 1991 to that in 1993?
Ensure brevity in your answer.  1.08. What is the ratio of the Aid flow (current US$) of Thailand in 1991 to that in 1993?
Offer a very short reply. 0.79. What is the ratio of the Aid flow (current US$) of Benin in 1992 to that in 1993?
Offer a terse response. 0.3. What is the ratio of the Aid flow (current US$) in Ethiopia in 1992 to that in 1993?
Give a very brief answer. 0.42. What is the ratio of the Aid flow (current US$) of Senegal in 1992 to that in 1993?
Your answer should be very brief. 1.16. What is the ratio of the Aid flow (current US$) of Thailand in 1992 to that in 1993?
Offer a very short reply. 1.58. What is the difference between the highest and the second highest Aid flow (current US$) of Benin?
Your answer should be compact. 3.40e+06. What is the difference between the highest and the second highest Aid flow (current US$) of Ethiopia?
Keep it short and to the point. 9.54e+06. What is the difference between the highest and the second highest Aid flow (current US$) in Senegal?
Keep it short and to the point. 3.48e+06. What is the difference between the highest and the second highest Aid flow (current US$) of Thailand?
Keep it short and to the point. 1.70e+05. What is the difference between the highest and the lowest Aid flow (current US$) in Benin?
Your answer should be very brief. 7.31e+06. What is the difference between the highest and the lowest Aid flow (current US$) in Ethiopia?
Your answer should be compact. 1.57e+07. What is the difference between the highest and the lowest Aid flow (current US$) of Senegal?
Keep it short and to the point. 4.85e+06. What is the difference between the highest and the lowest Aid flow (current US$) in Thailand?
Your response must be concise. 5.93e+06. 